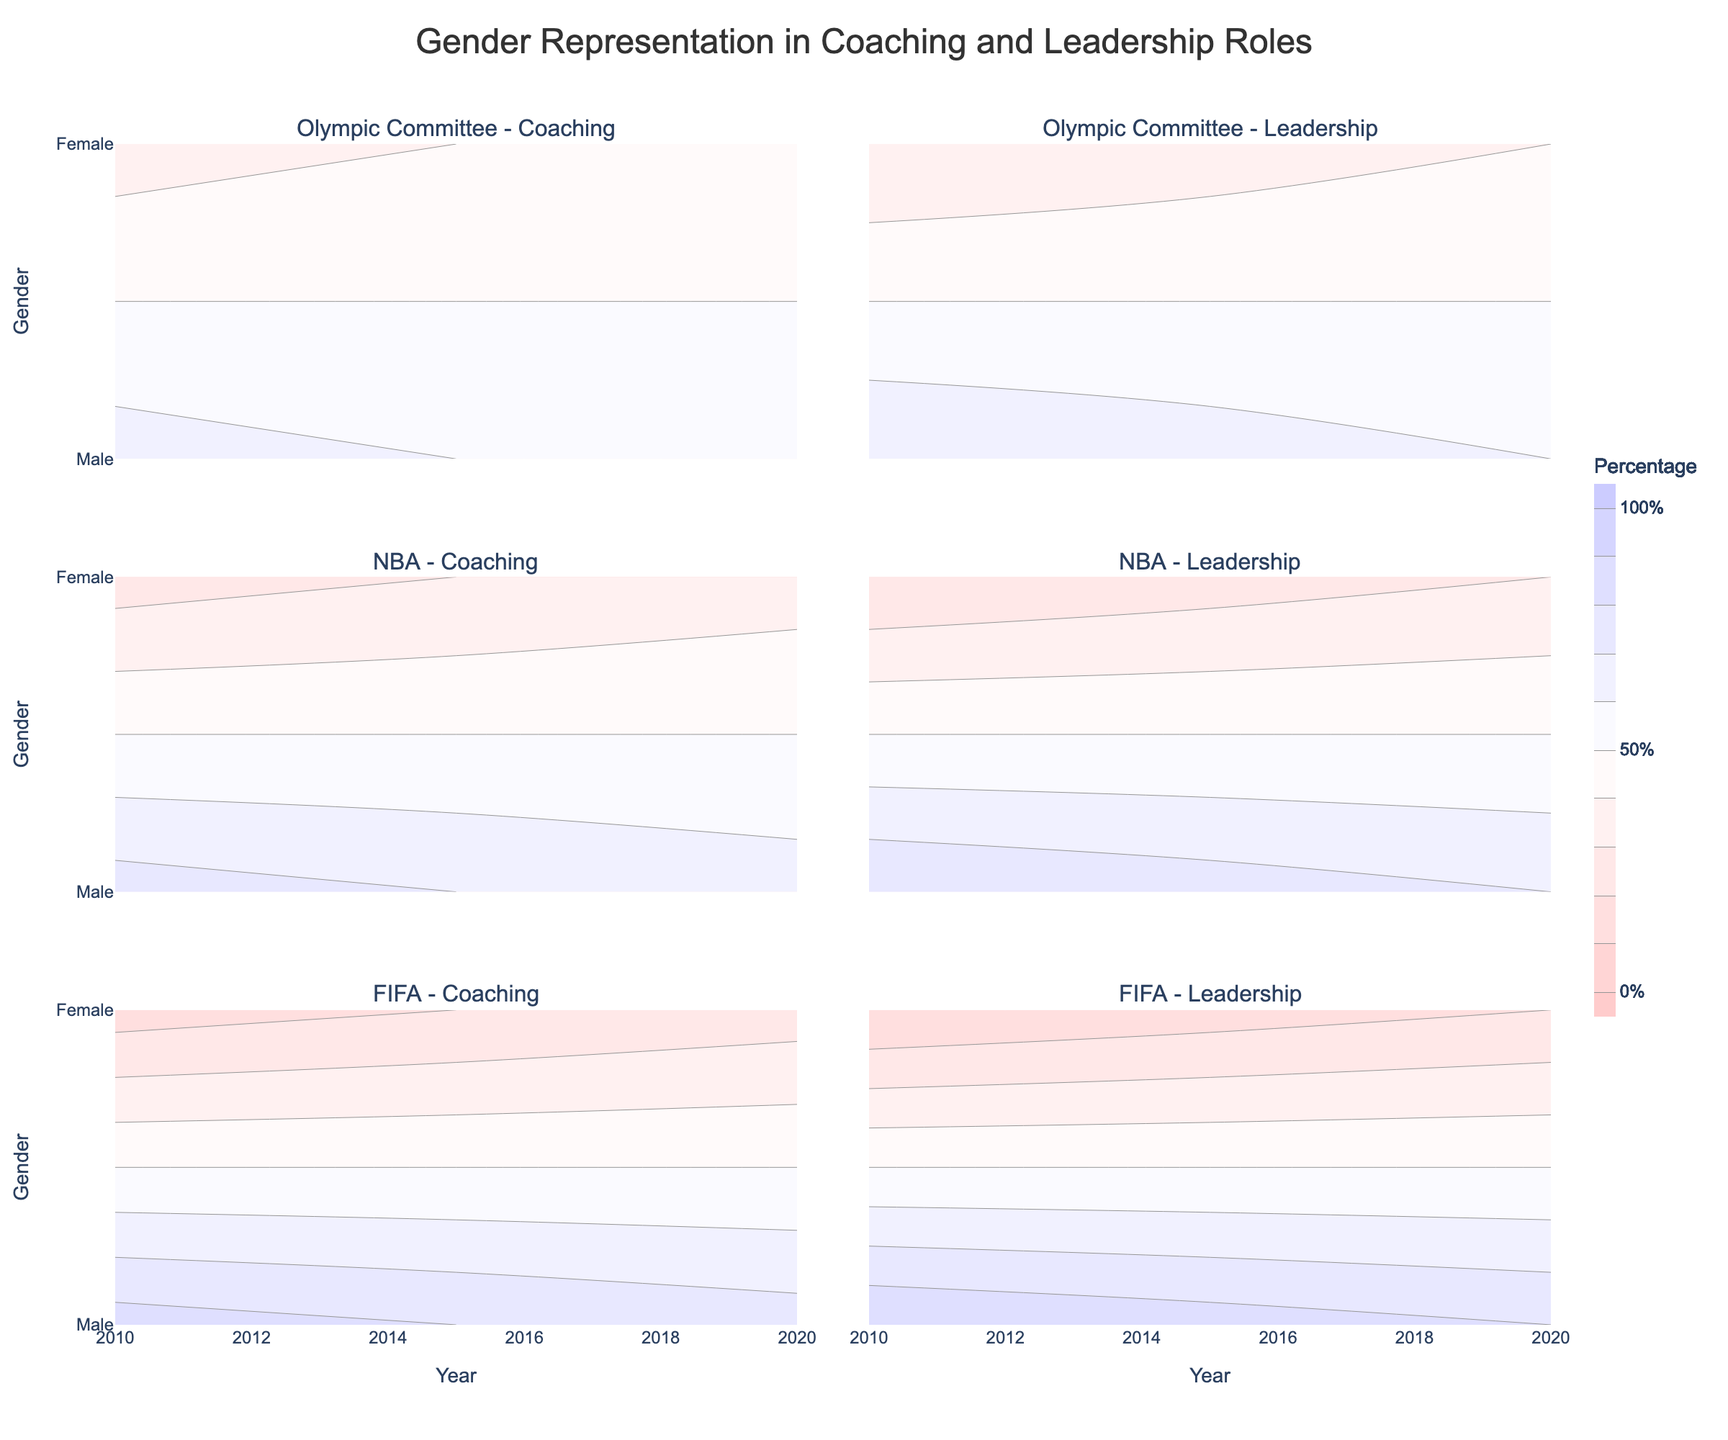How many organizations are represented in the figure? The title of each subplot provides the organization name. There are three unique organizations represented in the figure: Olympic Committee, NBA, and FIFA.
Answer: 3 How does the percentage of women in coaching roles in the NBA change from 2010 to 2020? Looking at the NBA subplot for coaching roles, the percentage of women increases from 25% in 2010 to 35% in 2020.
Answer: Increases Which organization had the highest percentage of men in leadership roles in 2010? By examining the 2010 data across all organization subplots for leadership roles, FIFA shows the highest percentage of men in leadership roles at 90%.
Answer: FIFA Compare the change in percentage of men in coaching roles between 2010 and 2020 for the Olympic Committee and FIFA. Which organization saw a bigger change? In the Olympic Committee subplot for coaching roles, the percentage of men decreased from 65% in 2010 to 55% in 2020 (a decrease of 10%). In FIFA, the percentage decreased from 85% in 2010 to 75% in 2020 (also a decrease of 10%). Both organizations saw the same change.
Answer: Same change What is the trend of the percentage of women in leadership roles in the Olympic Committee from 2010 to 2020? In the Olympic Committee subplot for leadership roles, the percentage of women increases from 30% in 2010 to 40% in 2020. This indicates a positive trend.
Answer: Increases What year had the lowest percentage of women in coaching roles across all organizations? Looking at the individual subplots for coaching roles across all years, FIFA in 2010 had the lowest percentage of women in coaching roles at 15%.
Answer: 2010 (FIFA) Is the percentage of men in leadership roles in the NBA higher or lower than in FIFA in 2020? When comparing the subplots for the NBA and FIFA in 2020 under leadership roles, the NBA has 70% men, whereas FIFA has 80% men. Therefore, the NBA has a lower percentage than FIFA.
Answer: Lower How does the change in the percentage of women in leadership roles from 2010 to 2020 differ between the Olympic Committee and NBA? For the Olympic Committee, the percentage of women in leadership roles increases from 30% to 40%. For the NBA, it increases from 20% to 30%. The Olympic Committee saw a 10% increase, and the NBA saw the same 10% increase.
Answer: No difference What general trend can be observed regarding the percentage of women in coaching roles over time for all organizations? In all subplots for coaching roles, we observe an increase in the percentage of women from 2010 to 2020 across all organizations (Olympic Committee, NBA, and FIFA).
Answer: Increasing trend 